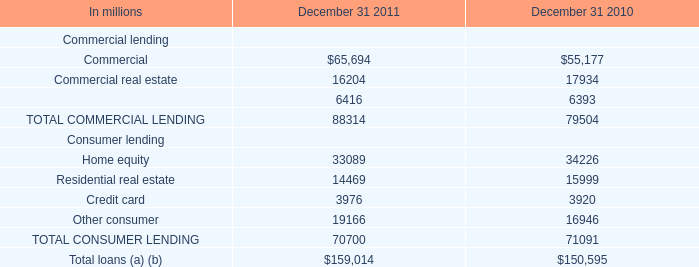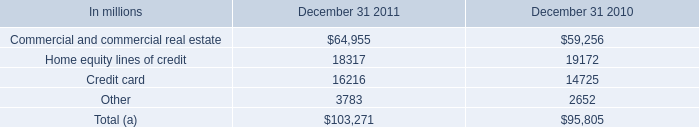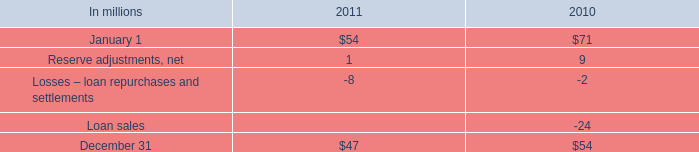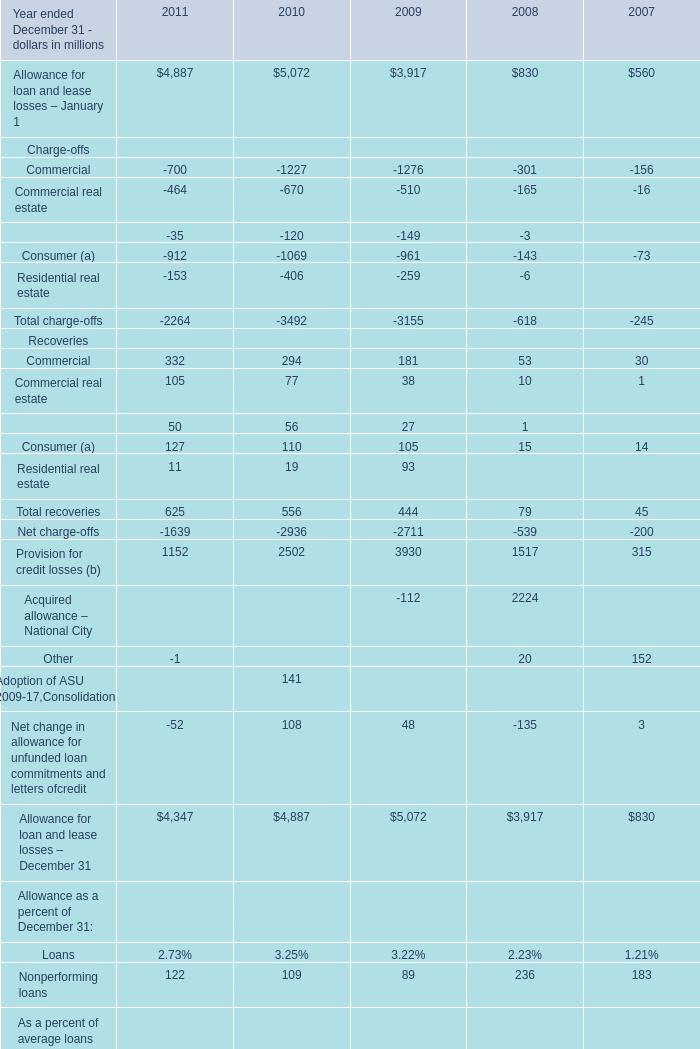In the year ended December 31 where Total recoveries is the highest, what's the increasing rate of the Recoveries for Commercial real estate? 
Computations: ((105 - 77) / 77)
Answer: 0.36364. 